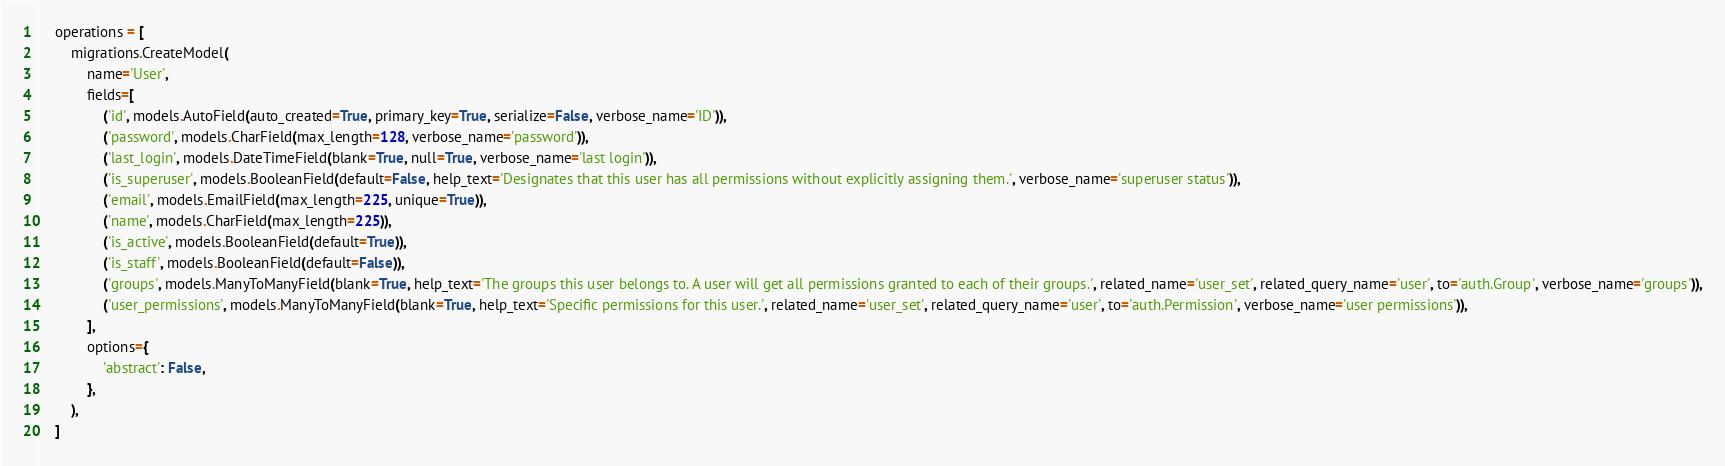Convert code to text. <code><loc_0><loc_0><loc_500><loc_500><_Python_>
    operations = [
        migrations.CreateModel(
            name='User',
            fields=[
                ('id', models.AutoField(auto_created=True, primary_key=True, serialize=False, verbose_name='ID')),
                ('password', models.CharField(max_length=128, verbose_name='password')),
                ('last_login', models.DateTimeField(blank=True, null=True, verbose_name='last login')),
                ('is_superuser', models.BooleanField(default=False, help_text='Designates that this user has all permissions without explicitly assigning them.', verbose_name='superuser status')),
                ('email', models.EmailField(max_length=225, unique=True)),
                ('name', models.CharField(max_length=225)),
                ('is_active', models.BooleanField(default=True)),
                ('is_staff', models.BooleanField(default=False)),
                ('groups', models.ManyToManyField(blank=True, help_text='The groups this user belongs to. A user will get all permissions granted to each of their groups.', related_name='user_set', related_query_name='user', to='auth.Group', verbose_name='groups')),
                ('user_permissions', models.ManyToManyField(blank=True, help_text='Specific permissions for this user.', related_name='user_set', related_query_name='user', to='auth.Permission', verbose_name='user permissions')),
            ],
            options={
                'abstract': False,
            },
        ),
    ]
</code> 